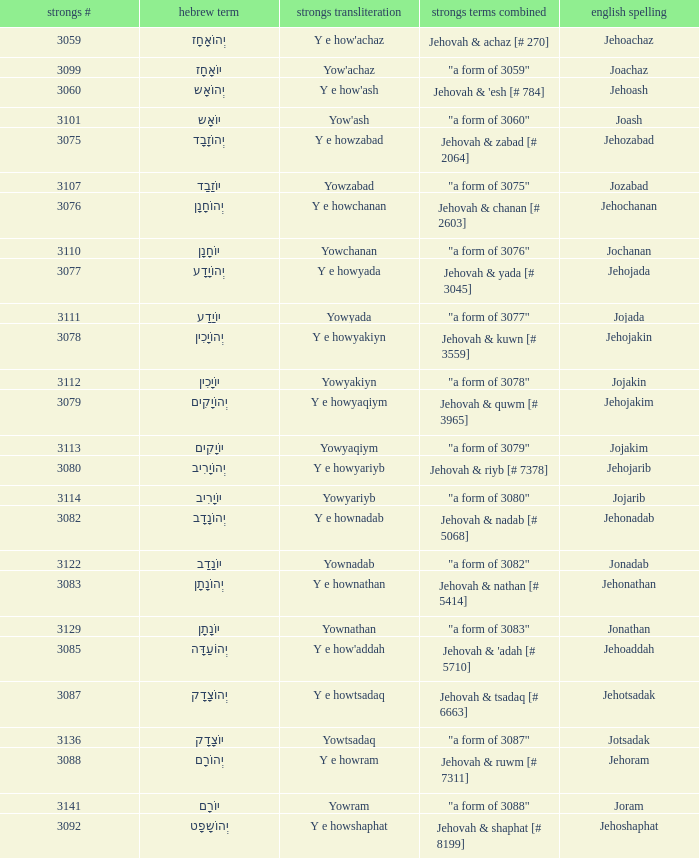How many strongs transliteration of the english spelling of the work jehojakin? 1.0. Can you parse all the data within this table? {'header': ['strongs #', 'hebrew term', 'strongs transliteration', 'strongs terms combined', 'english spelling'], 'rows': [['3059', 'יְהוֹאָחָז', "Y e how'achaz", 'Jehovah & achaz [# 270]', 'Jehoachaz'], ['3099', 'יוֹאָחָז', "Yow'achaz", '"a form of 3059"', 'Joachaz'], ['3060', 'יְהוֹאָש', "Y e how'ash", "Jehovah & 'esh [# 784]", 'Jehoash'], ['3101', 'יוֹאָש', "Yow'ash", '"a form of 3060"', 'Joash'], ['3075', 'יְהוֹזָבָד', 'Y e howzabad', 'Jehovah & zabad [# 2064]', 'Jehozabad'], ['3107', 'יוֹזָבָד', 'Yowzabad', '"a form of 3075"', 'Jozabad'], ['3076', 'יְהוֹחָנָן', 'Y e howchanan', 'Jehovah & chanan [# 2603]', 'Jehochanan'], ['3110', 'יוֹחָנָן', 'Yowchanan', '"a form of 3076"', 'Jochanan'], ['3077', 'יְהוֹיָדָע', 'Y e howyada', 'Jehovah & yada [# 3045]', 'Jehojada'], ['3111', 'יוֹיָדָע', 'Yowyada', '"a form of 3077"', 'Jojada'], ['3078', 'יְהוֹיָכִין', 'Y e howyakiyn', 'Jehovah & kuwn [# 3559]', 'Jehojakin'], ['3112', 'יוֹיָכִין', 'Yowyakiyn', '"a form of 3078"', 'Jojakin'], ['3079', 'יְהוֹיָקִים', 'Y e howyaqiym', 'Jehovah & quwm [# 3965]', 'Jehojakim'], ['3113', 'יוֹיָקִים', 'Yowyaqiym', '"a form of 3079"', 'Jojakim'], ['3080', 'יְהוֹיָרִיב', 'Y e howyariyb', 'Jehovah & riyb [# 7378]', 'Jehojarib'], ['3114', 'יוֹיָרִיב', 'Yowyariyb', '"a form of 3080"', 'Jojarib'], ['3082', 'יְהוֹנָדָב', 'Y e hownadab', 'Jehovah & nadab [# 5068]', 'Jehonadab'], ['3122', 'יוֹנָדָב', 'Yownadab', '"a form of 3082"', 'Jonadab'], ['3083', 'יְהוֹנָתָן', 'Y e hownathan', 'Jehovah & nathan [# 5414]', 'Jehonathan'], ['3129', 'יוֹנָתָן', 'Yownathan', '"a form of 3083"', 'Jonathan'], ['3085', 'יְהוֹעַדָּה', "Y e how'addah", "Jehovah & 'adah [# 5710]", 'Jehoaddah'], ['3087', 'יְהוֹצָדָק', 'Y e howtsadaq', 'Jehovah & tsadaq [# 6663]', 'Jehotsadak'], ['3136', 'יוֹצָדָק', 'Yowtsadaq', '"a form of 3087"', 'Jotsadak'], ['3088', 'יְהוֹרָם', 'Y e howram', 'Jehovah & ruwm [# 7311]', 'Jehoram'], ['3141', 'יוֹרָם', 'Yowram', '"a form of 3088"', 'Joram'], ['3092', 'יְהוֹשָפָט', 'Y e howshaphat', 'Jehovah & shaphat [# 8199]', 'Jehoshaphat']]} 